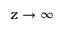Convert formula to latex. <formula><loc_0><loc_0><loc_500><loc_500>z \to \infty</formula> 